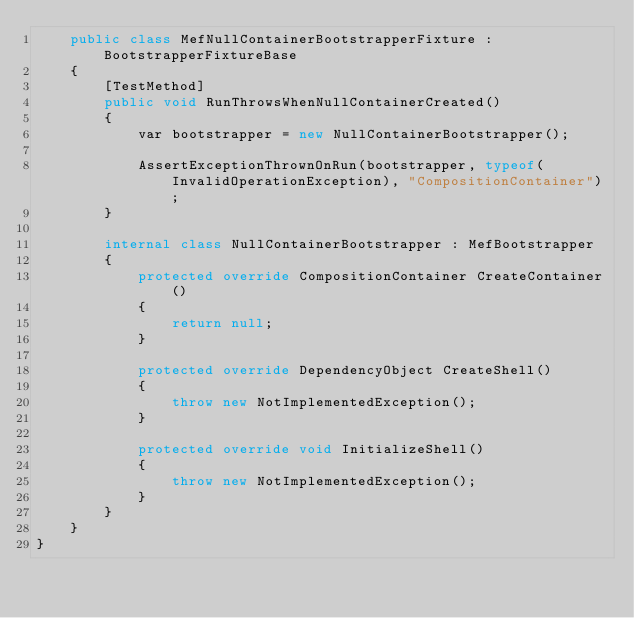Convert code to text. <code><loc_0><loc_0><loc_500><loc_500><_C#_>    public class MefNullContainerBootstrapperFixture : BootstrapperFixtureBase
    {
        [TestMethod]
        public void RunThrowsWhenNullContainerCreated()
        {
            var bootstrapper = new NullContainerBootstrapper();

            AssertExceptionThrownOnRun(bootstrapper, typeof(InvalidOperationException), "CompositionContainer");
        }

        internal class NullContainerBootstrapper : MefBootstrapper
        {
            protected override CompositionContainer CreateContainer()
            {
                return null;
            }

            protected override DependencyObject CreateShell()
            {
                throw new NotImplementedException();
            }

            protected override void InitializeShell()
            {
                throw new NotImplementedException();
            }
        }        
    }
}</code> 